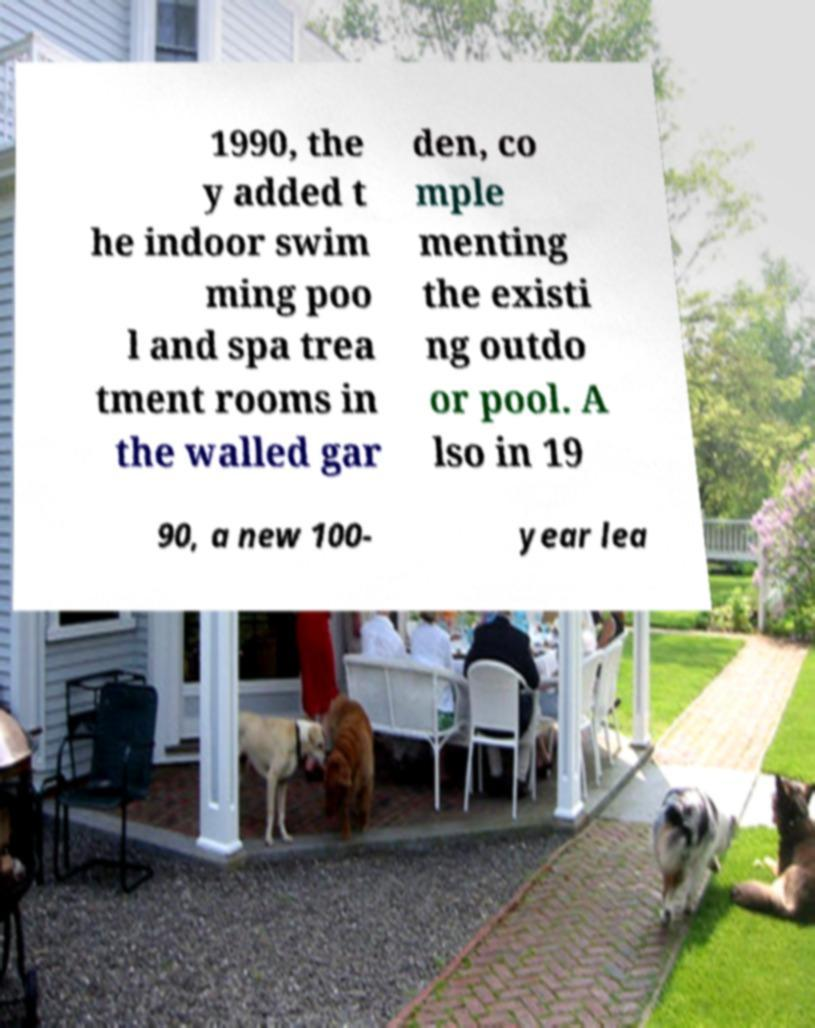There's text embedded in this image that I need extracted. Can you transcribe it verbatim? 1990, the y added t he indoor swim ming poo l and spa trea tment rooms in the walled gar den, co mple menting the existi ng outdo or pool. A lso in 19 90, a new 100- year lea 